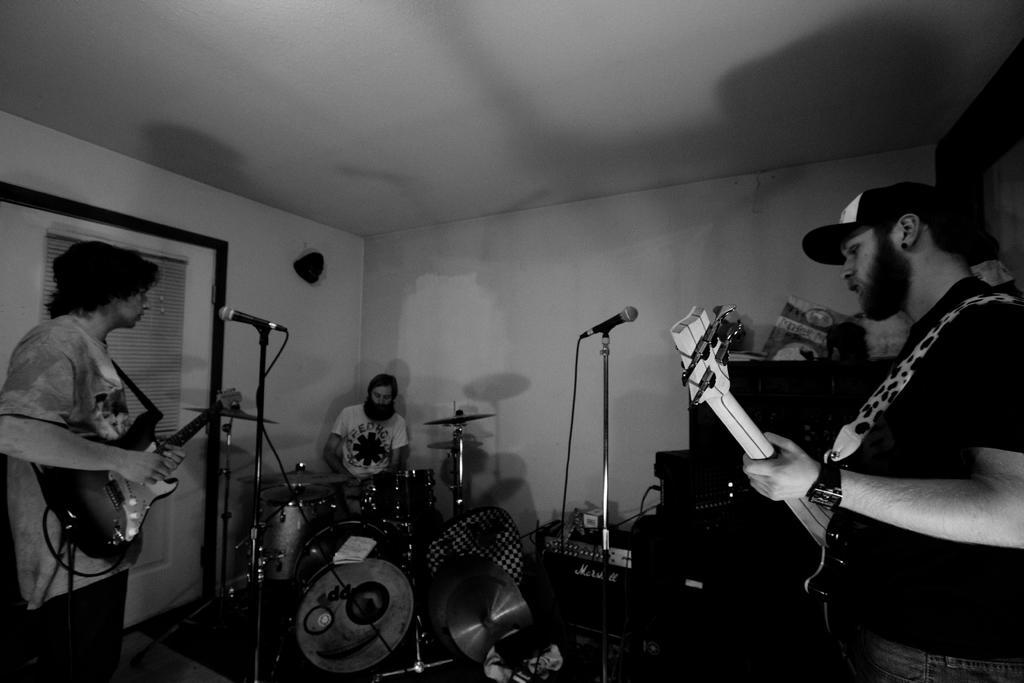Describe this image in one or two sentences. This picture shows two men holding guitar and playing and we see a other man seated and playing drums and we see microphones in front of them 